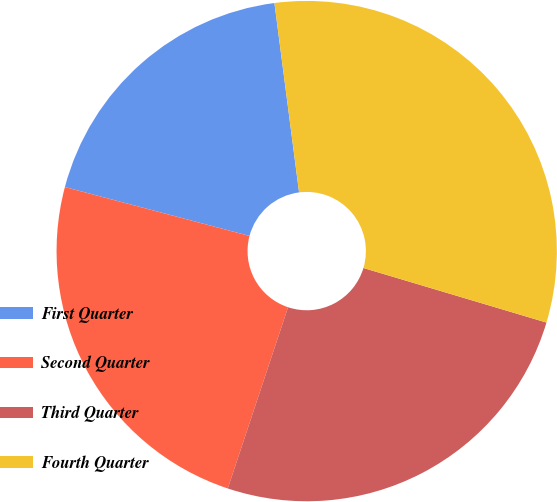<chart> <loc_0><loc_0><loc_500><loc_500><pie_chart><fcel>First Quarter<fcel>Second Quarter<fcel>Third Quarter<fcel>Fourth Quarter<nl><fcel>18.82%<fcel>24.01%<fcel>25.5%<fcel>31.67%<nl></chart> 